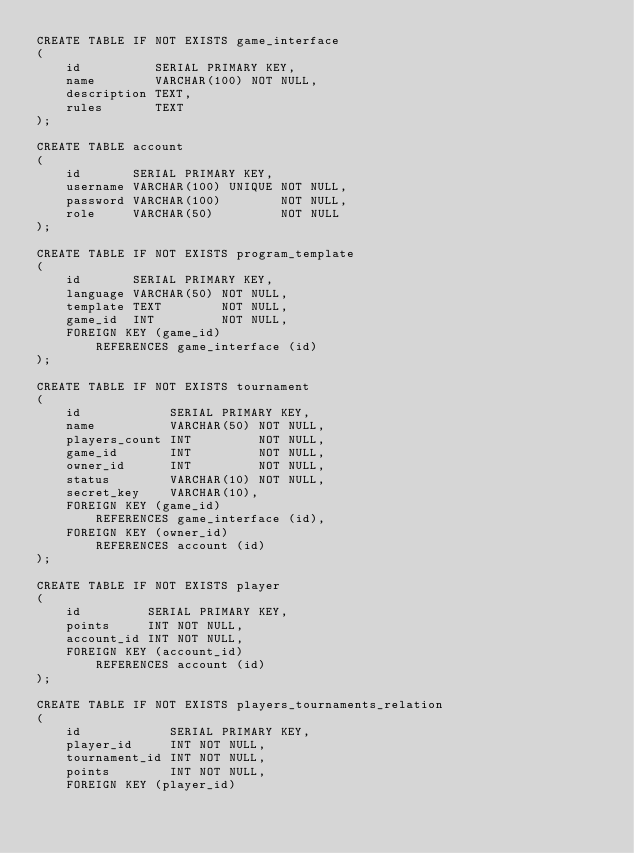<code> <loc_0><loc_0><loc_500><loc_500><_SQL_>CREATE TABLE IF NOT EXISTS game_interface
(
    id          SERIAL PRIMARY KEY,
    name        VARCHAR(100) NOT NULL,
    description TEXT,
    rules       TEXT
);

CREATE TABLE account
(
    id       SERIAL PRIMARY KEY,
    username VARCHAR(100) UNIQUE NOT NULL,
    password VARCHAR(100)        NOT NULL,
    role     VARCHAR(50)         NOT NULL
);

CREATE TABLE IF NOT EXISTS program_template
(
    id       SERIAL PRIMARY KEY,
    language VARCHAR(50) NOT NULL,
    template TEXT        NOT NULL,
    game_id  INT         NOT NULL,
    FOREIGN KEY (game_id)
        REFERENCES game_interface (id)
);

CREATE TABLE IF NOT EXISTS tournament
(
    id            SERIAL PRIMARY KEY,
    name          VARCHAR(50) NOT NULL,
    players_count INT         NOT NULL,
    game_id       INT         NOT NULL,
    owner_id      INT         NOT NULL,
    status        VARCHAR(10) NOT NULL,
    secret_key    VARCHAR(10),
    FOREIGN KEY (game_id)
        REFERENCES game_interface (id),
    FOREIGN KEY (owner_id)
        REFERENCES account (id)
);

CREATE TABLE IF NOT EXISTS player
(
    id         SERIAL PRIMARY KEY,
    points     INT NOT NULL,
    account_id INT NOT NULL,
    FOREIGN KEY (account_id)
        REFERENCES account (id)
);

CREATE TABLE IF NOT EXISTS players_tournaments_relation
(
    id            SERIAL PRIMARY KEY,
    player_id     INT NOT NULL,
    tournament_id INT NOT NULL,
    points        INT NOT NULL,
    FOREIGN KEY (player_id)</code> 